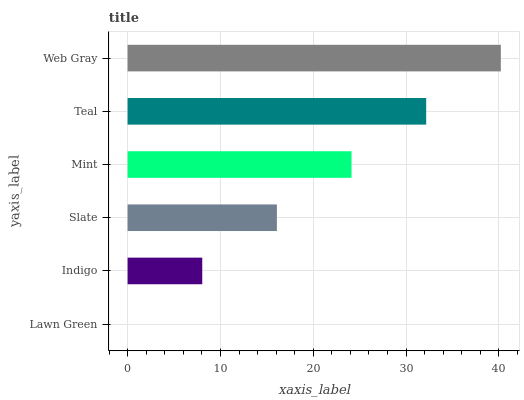Is Lawn Green the minimum?
Answer yes or no. Yes. Is Web Gray the maximum?
Answer yes or no. Yes. Is Indigo the minimum?
Answer yes or no. No. Is Indigo the maximum?
Answer yes or no. No. Is Indigo greater than Lawn Green?
Answer yes or no. Yes. Is Lawn Green less than Indigo?
Answer yes or no. Yes. Is Lawn Green greater than Indigo?
Answer yes or no. No. Is Indigo less than Lawn Green?
Answer yes or no. No. Is Mint the high median?
Answer yes or no. Yes. Is Slate the low median?
Answer yes or no. Yes. Is Indigo the high median?
Answer yes or no. No. Is Mint the low median?
Answer yes or no. No. 